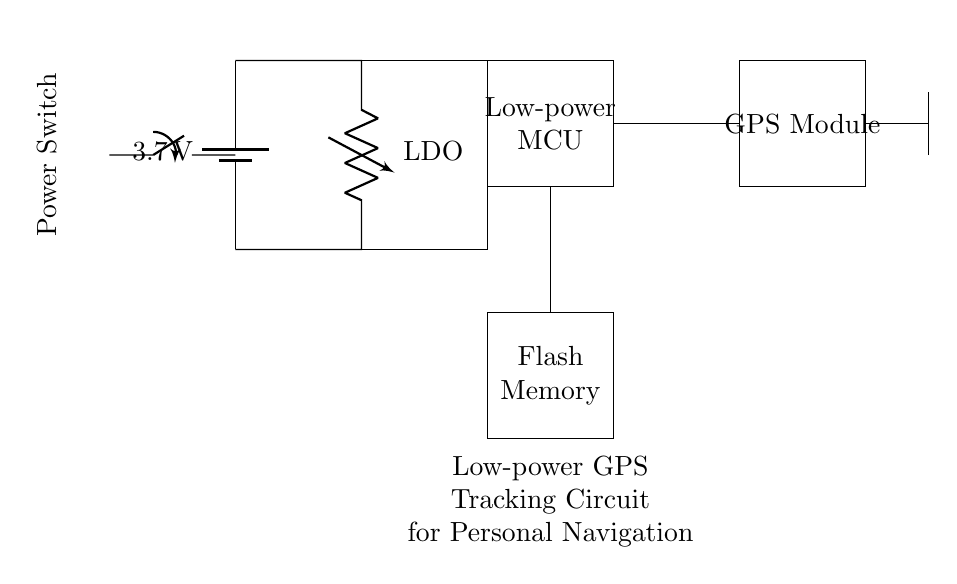What type of voltage regulator is used in this circuit? The circuit diagram labels the voltage regulator as "LDO," which stands for Low Dropout Regulator. This indicates the type of voltage regulation employed, focusing on maintaining voltage with minimal input-output differential.
Answer: LDO What is the function of the flash memory in this circuit? Flash memory is used for storing data like GPS coordinates and user settings in this circuit, providing non-volatile storage that retains information even without power.
Answer: Data storage What is the primary power supply voltage for this circuit? The circuit diagram indicates a battery with a label of "3.7 V," which signifies the nominal output voltage provided by the battery to power the circuit.
Answer: 3.7 V How many main components are visible in the circuit? The circuit includes four primary components: a battery, a voltage regulator, a microcontroller, and a GPS module. Adding the flash memory and antenna, you have six key components.
Answer: Four Explain why a low-power microcontroller is essential in this circuit. A low-power microcontroller is crucial because it helps minimize energy consumption, extending battery life and ensuring the device is effective for personal navigation over extended periods without frequent recharges.
Answer: Energy efficiency What type of switch is used to control the power supply? The circuit uses a "SPST" switch, which stands for Single Pole, Single Throw, indicating that it can connect or disconnect the power from the circuit in one position.
Answer: SPST Where does the GPS antenna connect in the circuit? The GPS antenna connects to the GPS module, indicated by a direct line leading from the GPS module to the antenna, ensuring effective signal reception for navigation.
Answer: GPS module 